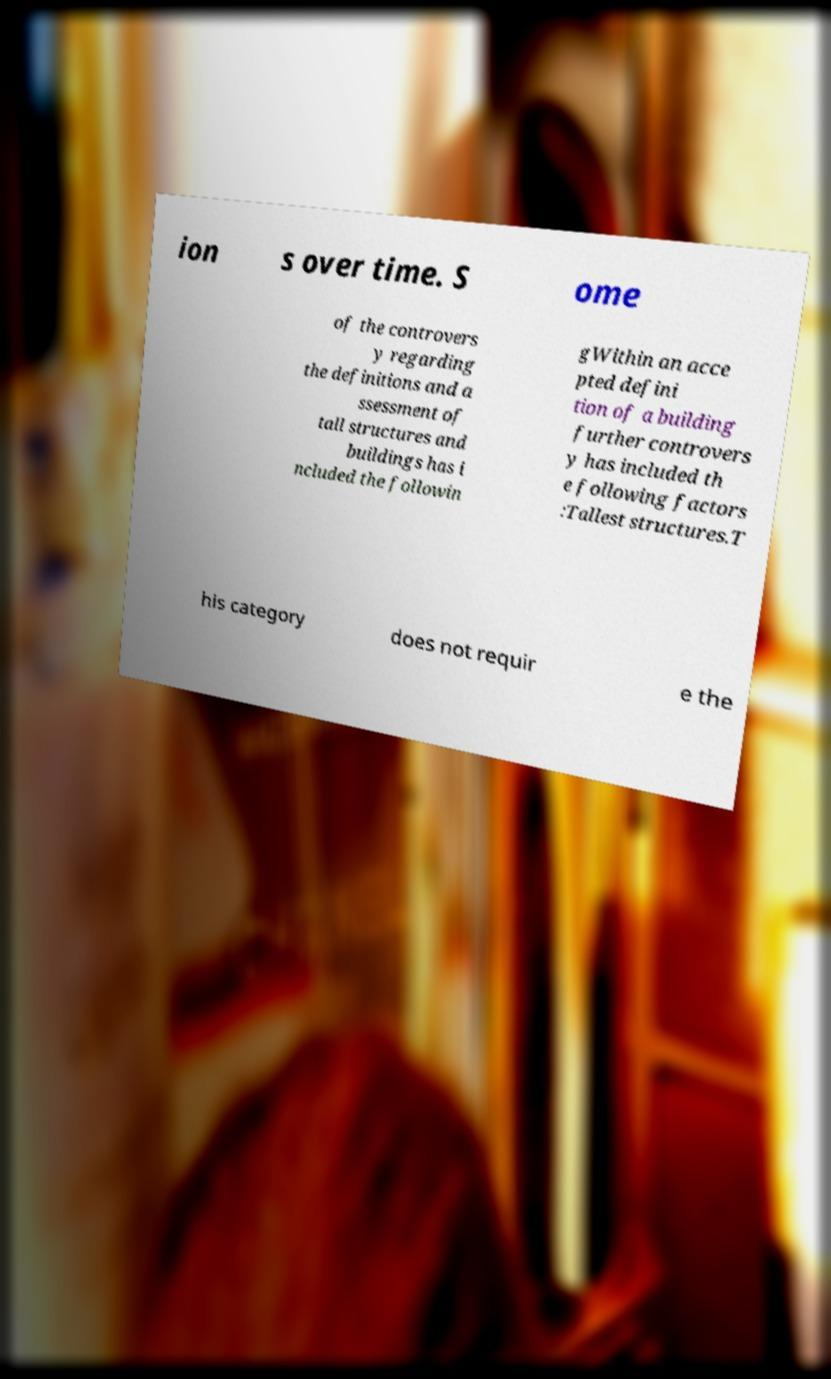Can you accurately transcribe the text from the provided image for me? ion s over time. S ome of the controvers y regarding the definitions and a ssessment of tall structures and buildings has i ncluded the followin gWithin an acce pted defini tion of a building further controvers y has included th e following factors :Tallest structures.T his category does not requir e the 